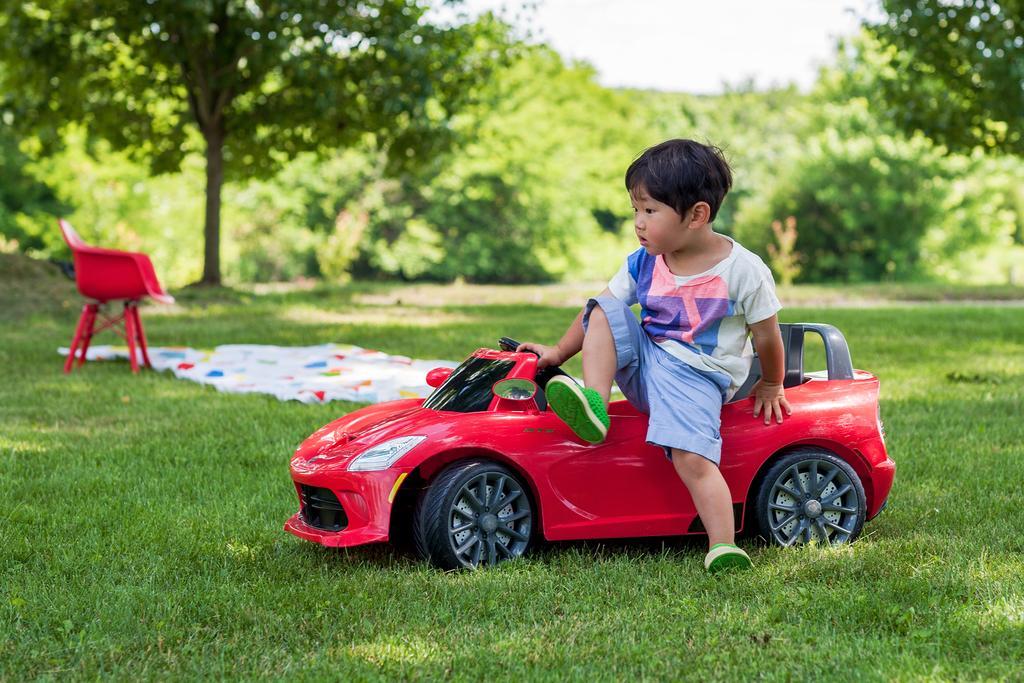Describe this image in one or two sentences. In the middle of the image, there is a kid sitting on the car, which is red in color. In the left of the image, there is a chair which is also red in color. In the background, we can see trees surrounding both side of the image. In the top middle, there is a sky white in color.
The whole image is covered with grass which is green in color. It looks as if the picture is taken in sunny day. 